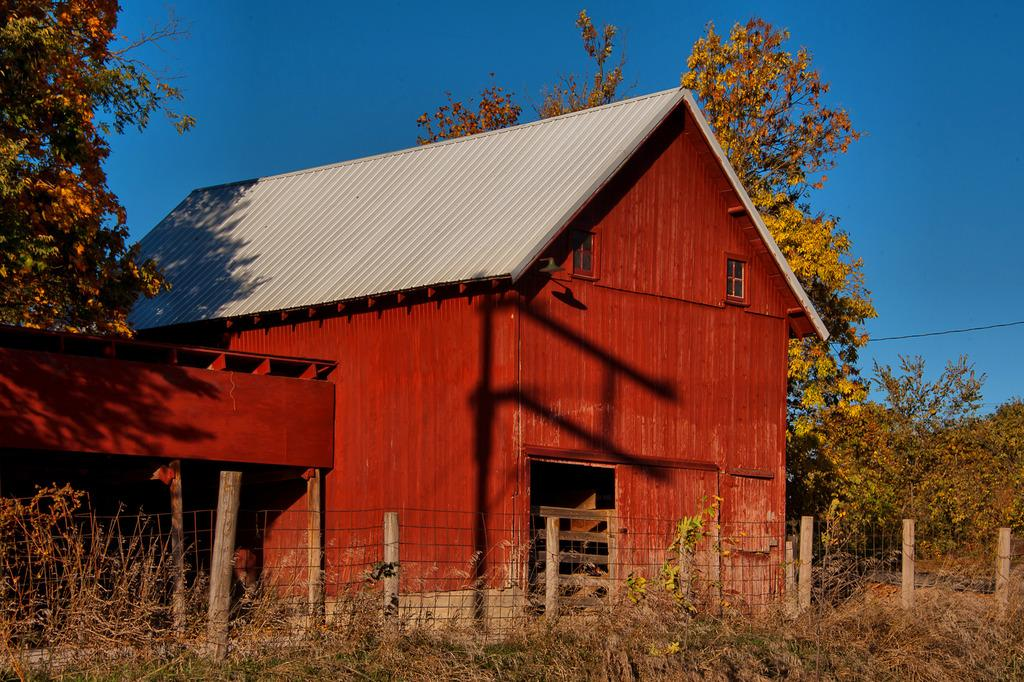What is the main structure in the center of the image? There is a house in the center of the image. What can be seen at the bottom of the image? There is a fence and wooden poles at the bottom of the image, along with grass. What is visible in the background of the image? There are trees and the sky visible in the background of the image. What type of thread is being used to decorate the house in the image? There is no thread visible in the image, and no indication that the house is being decorated with thread. 